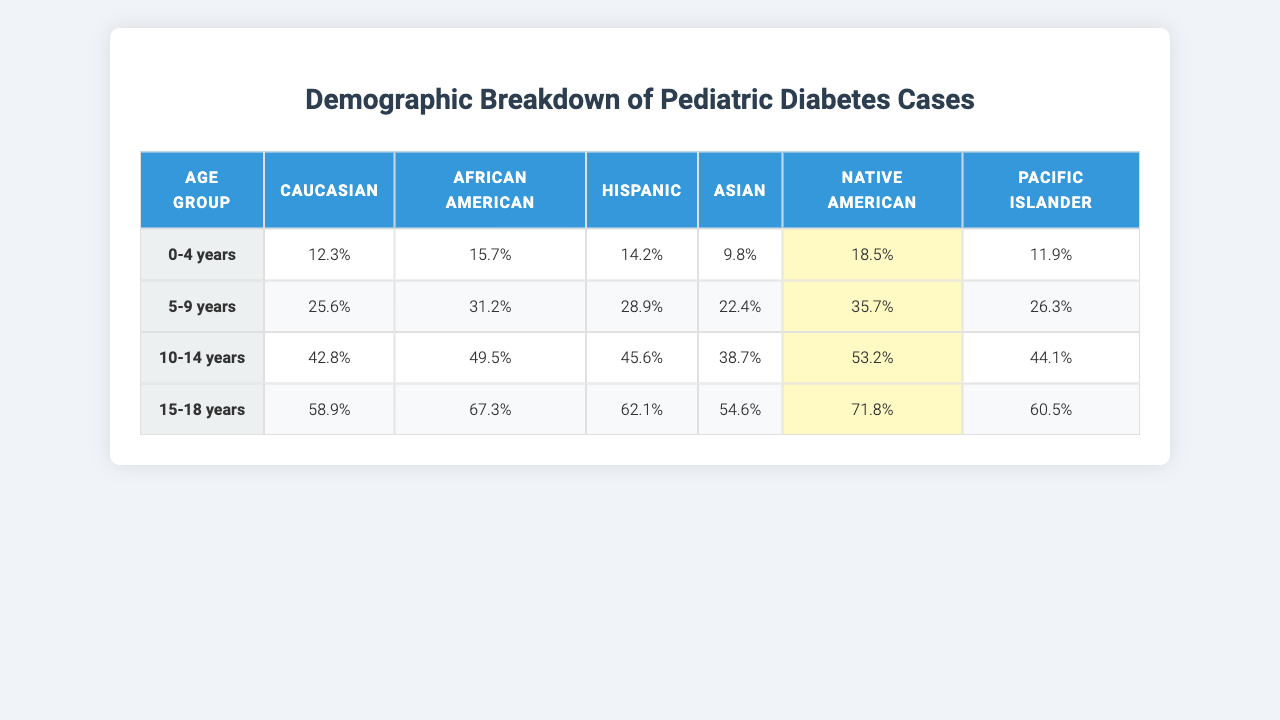What is the maximum percentage of pediatric diabetes cases in the age group 5-9 years? Looking at the "5-9 years" row, the highest percentage among ethnicities is for African American at 31.2%.
Answer: 31.2% Which age group has the highest percentage of Hispanic pediatric diabetes cases? In the "10-14 years" row, the percentage for Hispanic is 45.6%, which is the highest compared to other age groups.
Answer: 45.6% Is the percentage of Native American pediatric diabetes cases in the 15-18 years age group greater than that in the 0-4 years age group? The percentage in the 15-18 years age group is 71.8%, whereas in the 0-4 years age group it is 18.5%. Since 71.8% > 18.5%, the statement is true.
Answer: Yes What is the average percentage of pediatric diabetes cases across all ethnicities for the age group 10-14 years? To calculate the average, sum the percentages for each ethnicity in the 10-14 years row: (42.8 + 49.5 + 45.6 + 38.7 + 53.2 + 44.1) = 274.9. There are 6 ethnicities, so the average is 274.9 / 6 = 45.82.
Answer: 45.82 Which ethnicity has the lowest percentage of pediatric diabetes cases in the age group 0-4 years? The age group 0-4 years shows Asian with a percentage of 9.8%, which is the lowest compared to others.
Answer: Asian Is there a trend of increasing percentages of pediatric diabetes cases from the youngest to the oldest age groups for Hispanic ethnicity? Looking at the percentages: 0-4 years (14.2%), 5-9 years (28.9%), 10-14 years (45.6%), and 15-18 years (62.1%), we observe that the values are increasing. Therefore, the trend is present.
Answer: Yes What is the difference in pediatric diabetes cases percentage between Caucasian and Native American in the 15-18 years age group? The percentages are 58.9% for Caucasian and 71.8% for Native American in the 15-18 years age group. The difference is 71.8% - 58.9% = 12.9%.
Answer: 12.9% Which age group has consistently higher percentages for African American compared to Caucasian? When comparing the rows, the African American percentages are higher in both the 5-9 years (31.2% vs 25.6%) and 10-14 years (49.5% vs 42.8%), but in the 15-18 years age group, Caucasian is 58.9% compared to African American at 67.3%. Thus, the 5-9 years and 10-14 years age groups are where African American is higher.
Answer: 5-9 and 10-14 years What is the overall percentage increase for the Pacific Islander ethnicity from the 0-4 years to the 15-18 years age group? The Pacific Islander percentage in the 0-4 years age group is 11.9% and in the 15-18 years age group is 60.5%. The percentage increase is (60.5% - 11.9%) / 11.9% * 100 = 407.56%.
Answer: 407.56% 